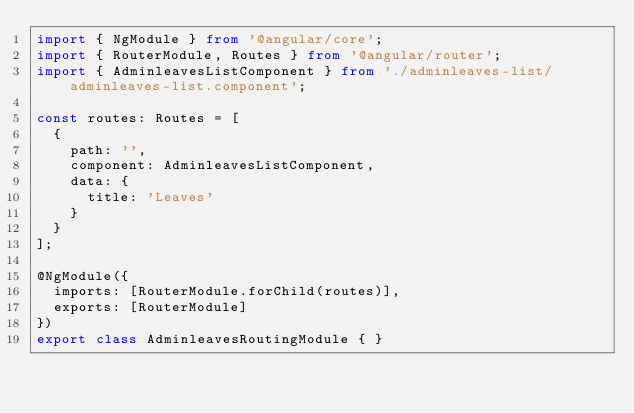<code> <loc_0><loc_0><loc_500><loc_500><_TypeScript_>import { NgModule } from '@angular/core';
import { RouterModule, Routes } from '@angular/router';
import { AdminleavesListComponent } from './adminleaves-list/adminleaves-list.component';

const routes: Routes = [
  {
    path: '',
    component: AdminleavesListComponent,
    data: {
      title: 'Leaves'
    }
  }
];

@NgModule({
  imports: [RouterModule.forChild(routes)],
  exports: [RouterModule]
})
export class AdminleavesRoutingModule { }
</code> 